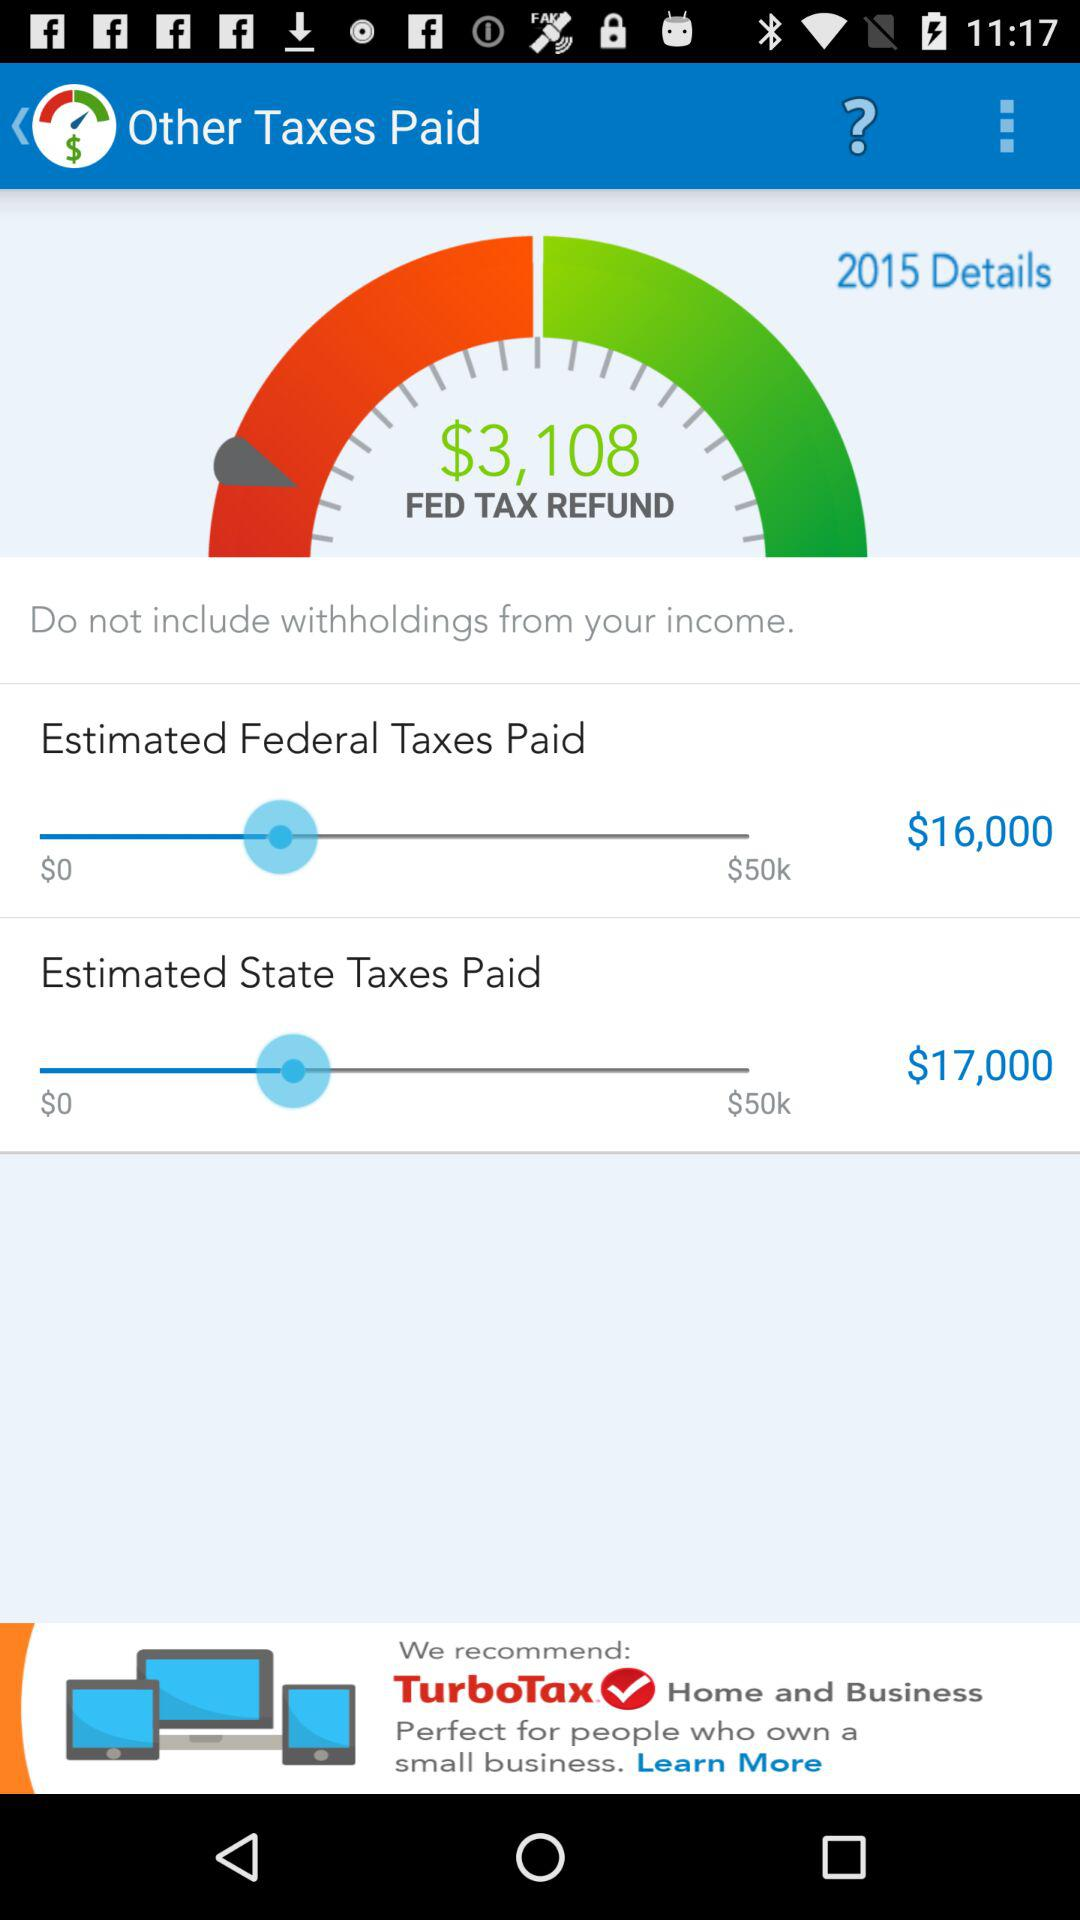What's the starting "Estimated State Taxes Paid" amount? The starting "Estimated State Taxes Paid" amount is $0. 